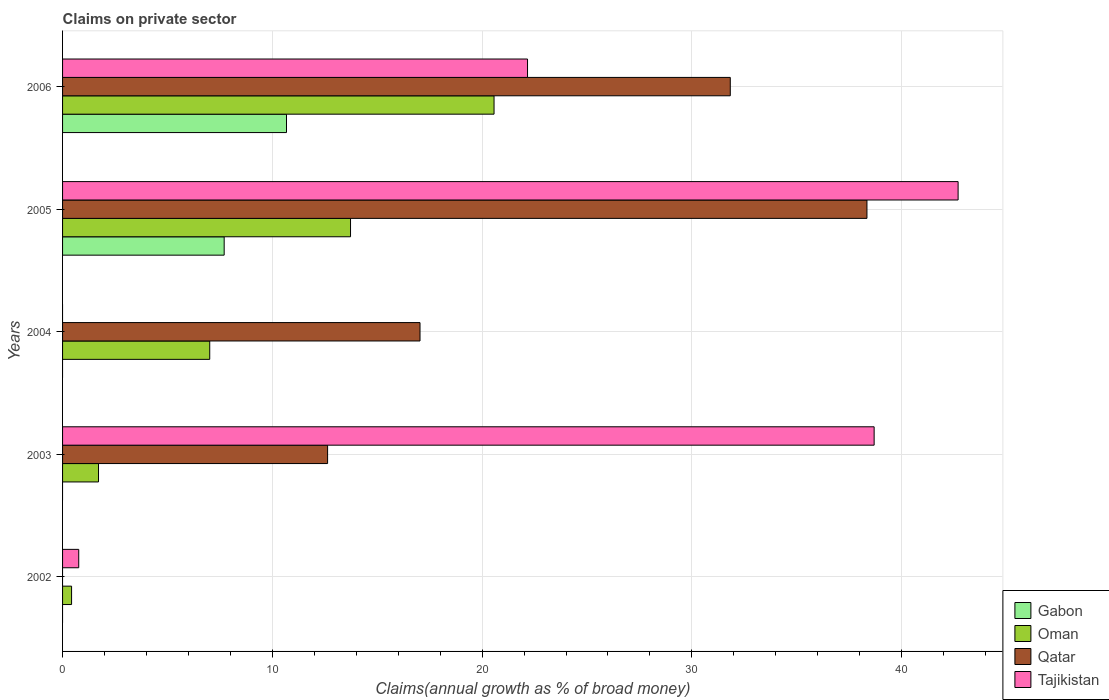How many bars are there on the 5th tick from the bottom?
Your response must be concise. 4. What is the percentage of broad money claimed on private sector in Tajikistan in 2002?
Keep it short and to the point. 0.77. Across all years, what is the maximum percentage of broad money claimed on private sector in Tajikistan?
Offer a terse response. 42.69. Across all years, what is the minimum percentage of broad money claimed on private sector in Tajikistan?
Give a very brief answer. 0. What is the total percentage of broad money claimed on private sector in Tajikistan in the graph?
Provide a succinct answer. 104.31. What is the difference between the percentage of broad money claimed on private sector in Tajikistan in 2005 and that in 2006?
Provide a succinct answer. 20.53. What is the difference between the percentage of broad money claimed on private sector in Oman in 2004 and the percentage of broad money claimed on private sector in Qatar in 2006?
Offer a terse response. -24.81. What is the average percentage of broad money claimed on private sector in Tajikistan per year?
Give a very brief answer. 20.86. In the year 2005, what is the difference between the percentage of broad money claimed on private sector in Oman and percentage of broad money claimed on private sector in Gabon?
Offer a terse response. 6.02. What is the ratio of the percentage of broad money claimed on private sector in Qatar in 2003 to that in 2005?
Make the answer very short. 0.33. Is the percentage of broad money claimed on private sector in Tajikistan in 2002 less than that in 2003?
Ensure brevity in your answer.  Yes. What is the difference between the highest and the second highest percentage of broad money claimed on private sector in Qatar?
Give a very brief answer. 6.52. What is the difference between the highest and the lowest percentage of broad money claimed on private sector in Gabon?
Your answer should be compact. 10.68. Is it the case that in every year, the sum of the percentage of broad money claimed on private sector in Tajikistan and percentage of broad money claimed on private sector in Oman is greater than the sum of percentage of broad money claimed on private sector in Qatar and percentage of broad money claimed on private sector in Gabon?
Your answer should be very brief. No. How many bars are there?
Provide a succinct answer. 15. Are all the bars in the graph horizontal?
Provide a succinct answer. Yes. What is the title of the graph?
Give a very brief answer. Claims on private sector. Does "Peru" appear as one of the legend labels in the graph?
Provide a short and direct response. No. What is the label or title of the X-axis?
Provide a succinct answer. Claims(annual growth as % of broad money). What is the Claims(annual growth as % of broad money) of Gabon in 2002?
Make the answer very short. 0. What is the Claims(annual growth as % of broad money) of Oman in 2002?
Give a very brief answer. 0.43. What is the Claims(annual growth as % of broad money) in Qatar in 2002?
Ensure brevity in your answer.  0. What is the Claims(annual growth as % of broad money) in Tajikistan in 2002?
Offer a terse response. 0.77. What is the Claims(annual growth as % of broad money) in Oman in 2003?
Your response must be concise. 1.71. What is the Claims(annual growth as % of broad money) in Qatar in 2003?
Your answer should be very brief. 12.63. What is the Claims(annual growth as % of broad money) of Tajikistan in 2003?
Your answer should be very brief. 38.69. What is the Claims(annual growth as % of broad money) of Oman in 2004?
Ensure brevity in your answer.  7.02. What is the Claims(annual growth as % of broad money) of Qatar in 2004?
Keep it short and to the point. 17.04. What is the Claims(annual growth as % of broad money) of Gabon in 2005?
Offer a terse response. 7.7. What is the Claims(annual growth as % of broad money) in Oman in 2005?
Provide a succinct answer. 13.73. What is the Claims(annual growth as % of broad money) in Qatar in 2005?
Your response must be concise. 38.35. What is the Claims(annual growth as % of broad money) of Tajikistan in 2005?
Ensure brevity in your answer.  42.69. What is the Claims(annual growth as % of broad money) of Gabon in 2006?
Provide a succinct answer. 10.68. What is the Claims(annual growth as % of broad money) of Oman in 2006?
Keep it short and to the point. 20.57. What is the Claims(annual growth as % of broad money) in Qatar in 2006?
Your answer should be compact. 31.83. What is the Claims(annual growth as % of broad money) in Tajikistan in 2006?
Ensure brevity in your answer.  22.17. Across all years, what is the maximum Claims(annual growth as % of broad money) in Gabon?
Ensure brevity in your answer.  10.68. Across all years, what is the maximum Claims(annual growth as % of broad money) in Oman?
Provide a short and direct response. 20.57. Across all years, what is the maximum Claims(annual growth as % of broad money) of Qatar?
Offer a very short reply. 38.35. Across all years, what is the maximum Claims(annual growth as % of broad money) of Tajikistan?
Offer a terse response. 42.69. Across all years, what is the minimum Claims(annual growth as % of broad money) in Gabon?
Your response must be concise. 0. Across all years, what is the minimum Claims(annual growth as % of broad money) of Oman?
Your answer should be compact. 0.43. Across all years, what is the minimum Claims(annual growth as % of broad money) of Qatar?
Offer a terse response. 0. What is the total Claims(annual growth as % of broad money) of Gabon in the graph?
Offer a terse response. 18.38. What is the total Claims(annual growth as % of broad money) in Oman in the graph?
Provide a short and direct response. 43.46. What is the total Claims(annual growth as % of broad money) in Qatar in the graph?
Your answer should be compact. 99.85. What is the total Claims(annual growth as % of broad money) in Tajikistan in the graph?
Provide a short and direct response. 104.31. What is the difference between the Claims(annual growth as % of broad money) in Oman in 2002 and that in 2003?
Offer a very short reply. -1.28. What is the difference between the Claims(annual growth as % of broad money) of Tajikistan in 2002 and that in 2003?
Make the answer very short. -37.92. What is the difference between the Claims(annual growth as % of broad money) of Oman in 2002 and that in 2004?
Make the answer very short. -6.59. What is the difference between the Claims(annual growth as % of broad money) in Oman in 2002 and that in 2005?
Offer a very short reply. -13.3. What is the difference between the Claims(annual growth as % of broad money) of Tajikistan in 2002 and that in 2005?
Your response must be concise. -41.92. What is the difference between the Claims(annual growth as % of broad money) in Oman in 2002 and that in 2006?
Ensure brevity in your answer.  -20.14. What is the difference between the Claims(annual growth as % of broad money) of Tajikistan in 2002 and that in 2006?
Your answer should be very brief. -21.39. What is the difference between the Claims(annual growth as % of broad money) of Oman in 2003 and that in 2004?
Your answer should be compact. -5.3. What is the difference between the Claims(annual growth as % of broad money) of Qatar in 2003 and that in 2004?
Your response must be concise. -4.41. What is the difference between the Claims(annual growth as % of broad money) of Oman in 2003 and that in 2005?
Provide a short and direct response. -12.01. What is the difference between the Claims(annual growth as % of broad money) of Qatar in 2003 and that in 2005?
Provide a short and direct response. -25.71. What is the difference between the Claims(annual growth as % of broad money) of Tajikistan in 2003 and that in 2005?
Keep it short and to the point. -4. What is the difference between the Claims(annual growth as % of broad money) of Oman in 2003 and that in 2006?
Offer a very short reply. -18.85. What is the difference between the Claims(annual growth as % of broad money) in Qatar in 2003 and that in 2006?
Your answer should be very brief. -19.2. What is the difference between the Claims(annual growth as % of broad money) of Tajikistan in 2003 and that in 2006?
Give a very brief answer. 16.52. What is the difference between the Claims(annual growth as % of broad money) of Oman in 2004 and that in 2005?
Your answer should be very brief. -6.71. What is the difference between the Claims(annual growth as % of broad money) of Qatar in 2004 and that in 2005?
Provide a succinct answer. -21.31. What is the difference between the Claims(annual growth as % of broad money) in Oman in 2004 and that in 2006?
Make the answer very short. -13.55. What is the difference between the Claims(annual growth as % of broad money) in Qatar in 2004 and that in 2006?
Your answer should be compact. -14.79. What is the difference between the Claims(annual growth as % of broad money) of Gabon in 2005 and that in 2006?
Ensure brevity in your answer.  -2.97. What is the difference between the Claims(annual growth as % of broad money) of Oman in 2005 and that in 2006?
Your response must be concise. -6.84. What is the difference between the Claims(annual growth as % of broad money) in Qatar in 2005 and that in 2006?
Offer a terse response. 6.52. What is the difference between the Claims(annual growth as % of broad money) in Tajikistan in 2005 and that in 2006?
Your answer should be compact. 20.53. What is the difference between the Claims(annual growth as % of broad money) in Oman in 2002 and the Claims(annual growth as % of broad money) in Qatar in 2003?
Provide a succinct answer. -12.2. What is the difference between the Claims(annual growth as % of broad money) of Oman in 2002 and the Claims(annual growth as % of broad money) of Tajikistan in 2003?
Offer a terse response. -38.26. What is the difference between the Claims(annual growth as % of broad money) of Oman in 2002 and the Claims(annual growth as % of broad money) of Qatar in 2004?
Your answer should be compact. -16.61. What is the difference between the Claims(annual growth as % of broad money) of Oman in 2002 and the Claims(annual growth as % of broad money) of Qatar in 2005?
Offer a terse response. -37.92. What is the difference between the Claims(annual growth as % of broad money) in Oman in 2002 and the Claims(annual growth as % of broad money) in Tajikistan in 2005?
Your response must be concise. -42.26. What is the difference between the Claims(annual growth as % of broad money) of Oman in 2002 and the Claims(annual growth as % of broad money) of Qatar in 2006?
Offer a terse response. -31.4. What is the difference between the Claims(annual growth as % of broad money) of Oman in 2002 and the Claims(annual growth as % of broad money) of Tajikistan in 2006?
Ensure brevity in your answer.  -21.74. What is the difference between the Claims(annual growth as % of broad money) of Oman in 2003 and the Claims(annual growth as % of broad money) of Qatar in 2004?
Your answer should be very brief. -15.33. What is the difference between the Claims(annual growth as % of broad money) in Oman in 2003 and the Claims(annual growth as % of broad money) in Qatar in 2005?
Keep it short and to the point. -36.63. What is the difference between the Claims(annual growth as % of broad money) of Oman in 2003 and the Claims(annual growth as % of broad money) of Tajikistan in 2005?
Provide a succinct answer. -40.98. What is the difference between the Claims(annual growth as % of broad money) in Qatar in 2003 and the Claims(annual growth as % of broad money) in Tajikistan in 2005?
Provide a short and direct response. -30.06. What is the difference between the Claims(annual growth as % of broad money) of Oman in 2003 and the Claims(annual growth as % of broad money) of Qatar in 2006?
Make the answer very short. -30.12. What is the difference between the Claims(annual growth as % of broad money) in Oman in 2003 and the Claims(annual growth as % of broad money) in Tajikistan in 2006?
Offer a very short reply. -20.45. What is the difference between the Claims(annual growth as % of broad money) in Qatar in 2003 and the Claims(annual growth as % of broad money) in Tajikistan in 2006?
Offer a very short reply. -9.53. What is the difference between the Claims(annual growth as % of broad money) of Oman in 2004 and the Claims(annual growth as % of broad money) of Qatar in 2005?
Offer a very short reply. -31.33. What is the difference between the Claims(annual growth as % of broad money) of Oman in 2004 and the Claims(annual growth as % of broad money) of Tajikistan in 2005?
Offer a very short reply. -35.68. What is the difference between the Claims(annual growth as % of broad money) in Qatar in 2004 and the Claims(annual growth as % of broad money) in Tajikistan in 2005?
Your answer should be compact. -25.65. What is the difference between the Claims(annual growth as % of broad money) in Oman in 2004 and the Claims(annual growth as % of broad money) in Qatar in 2006?
Provide a short and direct response. -24.81. What is the difference between the Claims(annual growth as % of broad money) of Oman in 2004 and the Claims(annual growth as % of broad money) of Tajikistan in 2006?
Your answer should be very brief. -15.15. What is the difference between the Claims(annual growth as % of broad money) of Qatar in 2004 and the Claims(annual growth as % of broad money) of Tajikistan in 2006?
Ensure brevity in your answer.  -5.13. What is the difference between the Claims(annual growth as % of broad money) in Gabon in 2005 and the Claims(annual growth as % of broad money) in Oman in 2006?
Ensure brevity in your answer.  -12.86. What is the difference between the Claims(annual growth as % of broad money) in Gabon in 2005 and the Claims(annual growth as % of broad money) in Qatar in 2006?
Provide a succinct answer. -24.13. What is the difference between the Claims(annual growth as % of broad money) in Gabon in 2005 and the Claims(annual growth as % of broad money) in Tajikistan in 2006?
Offer a terse response. -14.46. What is the difference between the Claims(annual growth as % of broad money) in Oman in 2005 and the Claims(annual growth as % of broad money) in Qatar in 2006?
Offer a terse response. -18.1. What is the difference between the Claims(annual growth as % of broad money) in Oman in 2005 and the Claims(annual growth as % of broad money) in Tajikistan in 2006?
Make the answer very short. -8.44. What is the difference between the Claims(annual growth as % of broad money) in Qatar in 2005 and the Claims(annual growth as % of broad money) in Tajikistan in 2006?
Offer a very short reply. 16.18. What is the average Claims(annual growth as % of broad money) of Gabon per year?
Offer a very short reply. 3.68. What is the average Claims(annual growth as % of broad money) in Oman per year?
Provide a succinct answer. 8.69. What is the average Claims(annual growth as % of broad money) in Qatar per year?
Keep it short and to the point. 19.97. What is the average Claims(annual growth as % of broad money) in Tajikistan per year?
Make the answer very short. 20.86. In the year 2002, what is the difference between the Claims(annual growth as % of broad money) of Oman and Claims(annual growth as % of broad money) of Tajikistan?
Provide a short and direct response. -0.34. In the year 2003, what is the difference between the Claims(annual growth as % of broad money) in Oman and Claims(annual growth as % of broad money) in Qatar?
Offer a terse response. -10.92. In the year 2003, what is the difference between the Claims(annual growth as % of broad money) of Oman and Claims(annual growth as % of broad money) of Tajikistan?
Offer a very short reply. -36.97. In the year 2003, what is the difference between the Claims(annual growth as % of broad money) in Qatar and Claims(annual growth as % of broad money) in Tajikistan?
Offer a terse response. -26.05. In the year 2004, what is the difference between the Claims(annual growth as % of broad money) in Oman and Claims(annual growth as % of broad money) in Qatar?
Offer a very short reply. -10.02. In the year 2005, what is the difference between the Claims(annual growth as % of broad money) of Gabon and Claims(annual growth as % of broad money) of Oman?
Keep it short and to the point. -6.02. In the year 2005, what is the difference between the Claims(annual growth as % of broad money) in Gabon and Claims(annual growth as % of broad money) in Qatar?
Your answer should be very brief. -30.64. In the year 2005, what is the difference between the Claims(annual growth as % of broad money) of Gabon and Claims(annual growth as % of broad money) of Tajikistan?
Ensure brevity in your answer.  -34.99. In the year 2005, what is the difference between the Claims(annual growth as % of broad money) in Oman and Claims(annual growth as % of broad money) in Qatar?
Offer a very short reply. -24.62. In the year 2005, what is the difference between the Claims(annual growth as % of broad money) in Oman and Claims(annual growth as % of broad money) in Tajikistan?
Provide a short and direct response. -28.96. In the year 2005, what is the difference between the Claims(annual growth as % of broad money) of Qatar and Claims(annual growth as % of broad money) of Tajikistan?
Your answer should be very brief. -4.35. In the year 2006, what is the difference between the Claims(annual growth as % of broad money) of Gabon and Claims(annual growth as % of broad money) of Oman?
Offer a very short reply. -9.89. In the year 2006, what is the difference between the Claims(annual growth as % of broad money) in Gabon and Claims(annual growth as % of broad money) in Qatar?
Provide a short and direct response. -21.16. In the year 2006, what is the difference between the Claims(annual growth as % of broad money) of Gabon and Claims(annual growth as % of broad money) of Tajikistan?
Keep it short and to the point. -11.49. In the year 2006, what is the difference between the Claims(annual growth as % of broad money) in Oman and Claims(annual growth as % of broad money) in Qatar?
Provide a succinct answer. -11.26. In the year 2006, what is the difference between the Claims(annual growth as % of broad money) in Oman and Claims(annual growth as % of broad money) in Tajikistan?
Keep it short and to the point. -1.6. In the year 2006, what is the difference between the Claims(annual growth as % of broad money) in Qatar and Claims(annual growth as % of broad money) in Tajikistan?
Give a very brief answer. 9.67. What is the ratio of the Claims(annual growth as % of broad money) of Oman in 2002 to that in 2003?
Provide a short and direct response. 0.25. What is the ratio of the Claims(annual growth as % of broad money) of Tajikistan in 2002 to that in 2003?
Offer a very short reply. 0.02. What is the ratio of the Claims(annual growth as % of broad money) of Oman in 2002 to that in 2004?
Offer a very short reply. 0.06. What is the ratio of the Claims(annual growth as % of broad money) in Oman in 2002 to that in 2005?
Offer a very short reply. 0.03. What is the ratio of the Claims(annual growth as % of broad money) of Tajikistan in 2002 to that in 2005?
Your answer should be very brief. 0.02. What is the ratio of the Claims(annual growth as % of broad money) of Oman in 2002 to that in 2006?
Your answer should be compact. 0.02. What is the ratio of the Claims(annual growth as % of broad money) in Tajikistan in 2002 to that in 2006?
Your answer should be compact. 0.03. What is the ratio of the Claims(annual growth as % of broad money) of Oman in 2003 to that in 2004?
Offer a terse response. 0.24. What is the ratio of the Claims(annual growth as % of broad money) of Qatar in 2003 to that in 2004?
Give a very brief answer. 0.74. What is the ratio of the Claims(annual growth as % of broad money) of Oman in 2003 to that in 2005?
Your answer should be compact. 0.12. What is the ratio of the Claims(annual growth as % of broad money) of Qatar in 2003 to that in 2005?
Your response must be concise. 0.33. What is the ratio of the Claims(annual growth as % of broad money) of Tajikistan in 2003 to that in 2005?
Your answer should be compact. 0.91. What is the ratio of the Claims(annual growth as % of broad money) in Oman in 2003 to that in 2006?
Give a very brief answer. 0.08. What is the ratio of the Claims(annual growth as % of broad money) of Qatar in 2003 to that in 2006?
Your response must be concise. 0.4. What is the ratio of the Claims(annual growth as % of broad money) of Tajikistan in 2003 to that in 2006?
Your response must be concise. 1.75. What is the ratio of the Claims(annual growth as % of broad money) in Oman in 2004 to that in 2005?
Your answer should be compact. 0.51. What is the ratio of the Claims(annual growth as % of broad money) in Qatar in 2004 to that in 2005?
Offer a very short reply. 0.44. What is the ratio of the Claims(annual growth as % of broad money) in Oman in 2004 to that in 2006?
Your answer should be very brief. 0.34. What is the ratio of the Claims(annual growth as % of broad money) of Qatar in 2004 to that in 2006?
Your answer should be compact. 0.54. What is the ratio of the Claims(annual growth as % of broad money) in Gabon in 2005 to that in 2006?
Make the answer very short. 0.72. What is the ratio of the Claims(annual growth as % of broad money) of Oman in 2005 to that in 2006?
Ensure brevity in your answer.  0.67. What is the ratio of the Claims(annual growth as % of broad money) in Qatar in 2005 to that in 2006?
Provide a short and direct response. 1.2. What is the ratio of the Claims(annual growth as % of broad money) in Tajikistan in 2005 to that in 2006?
Your answer should be compact. 1.93. What is the difference between the highest and the second highest Claims(annual growth as % of broad money) in Oman?
Offer a terse response. 6.84. What is the difference between the highest and the second highest Claims(annual growth as % of broad money) in Qatar?
Your answer should be very brief. 6.52. What is the difference between the highest and the second highest Claims(annual growth as % of broad money) in Tajikistan?
Your answer should be very brief. 4. What is the difference between the highest and the lowest Claims(annual growth as % of broad money) in Gabon?
Make the answer very short. 10.68. What is the difference between the highest and the lowest Claims(annual growth as % of broad money) of Oman?
Provide a short and direct response. 20.14. What is the difference between the highest and the lowest Claims(annual growth as % of broad money) in Qatar?
Offer a very short reply. 38.35. What is the difference between the highest and the lowest Claims(annual growth as % of broad money) in Tajikistan?
Make the answer very short. 42.69. 